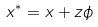<formula> <loc_0><loc_0><loc_500><loc_500>x ^ { * } = x + z \phi</formula> 